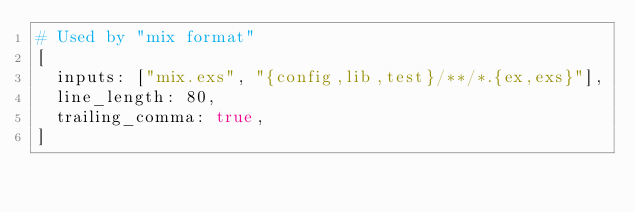<code> <loc_0><loc_0><loc_500><loc_500><_Elixir_># Used by "mix format"
[
  inputs: ["mix.exs", "{config,lib,test}/**/*.{ex,exs}"],
  line_length: 80,
  trailing_comma: true,
]
</code> 